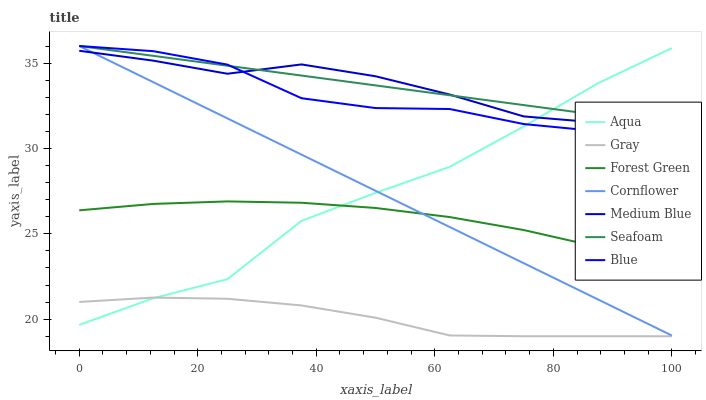Does Gray have the minimum area under the curve?
Answer yes or no. Yes. Does Seafoam have the maximum area under the curve?
Answer yes or no. Yes. Does Cornflower have the minimum area under the curve?
Answer yes or no. No. Does Cornflower have the maximum area under the curve?
Answer yes or no. No. Is Cornflower the smoothest?
Answer yes or no. Yes. Is Aqua the roughest?
Answer yes or no. Yes. Is Gray the smoothest?
Answer yes or no. No. Is Gray the roughest?
Answer yes or no. No. Does Cornflower have the lowest value?
Answer yes or no. No. Does Gray have the highest value?
Answer yes or no. No. Is Gray less than Seafoam?
Answer yes or no. Yes. Is Blue greater than Forest Green?
Answer yes or no. Yes. Does Gray intersect Seafoam?
Answer yes or no. No. 